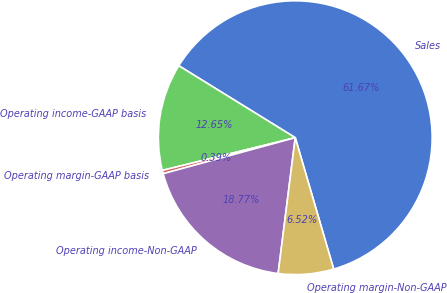<chart> <loc_0><loc_0><loc_500><loc_500><pie_chart><fcel>Sales<fcel>Operating income-GAAP basis<fcel>Operating margin-GAAP basis<fcel>Operating income-Non-GAAP<fcel>Operating margin-Non-GAAP<nl><fcel>61.66%<fcel>12.65%<fcel>0.39%<fcel>18.77%<fcel>6.52%<nl></chart> 